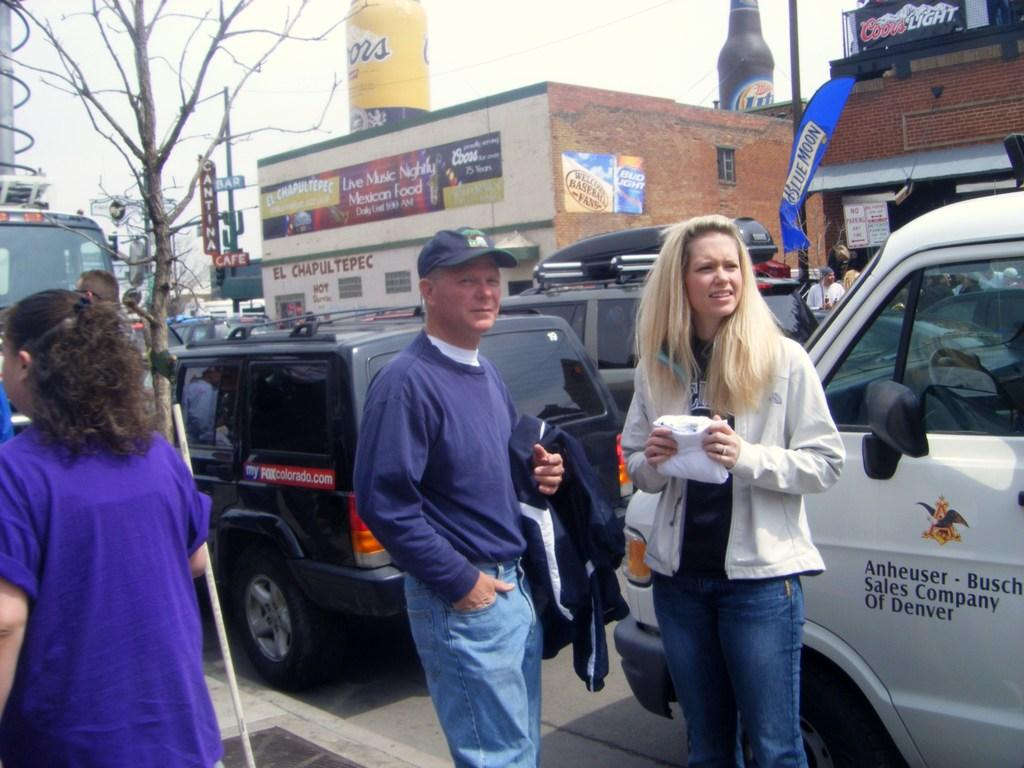<image>
Relay a brief, clear account of the picture shown. People standing in front of a white van which says "Anheuser-Busch" on it. 